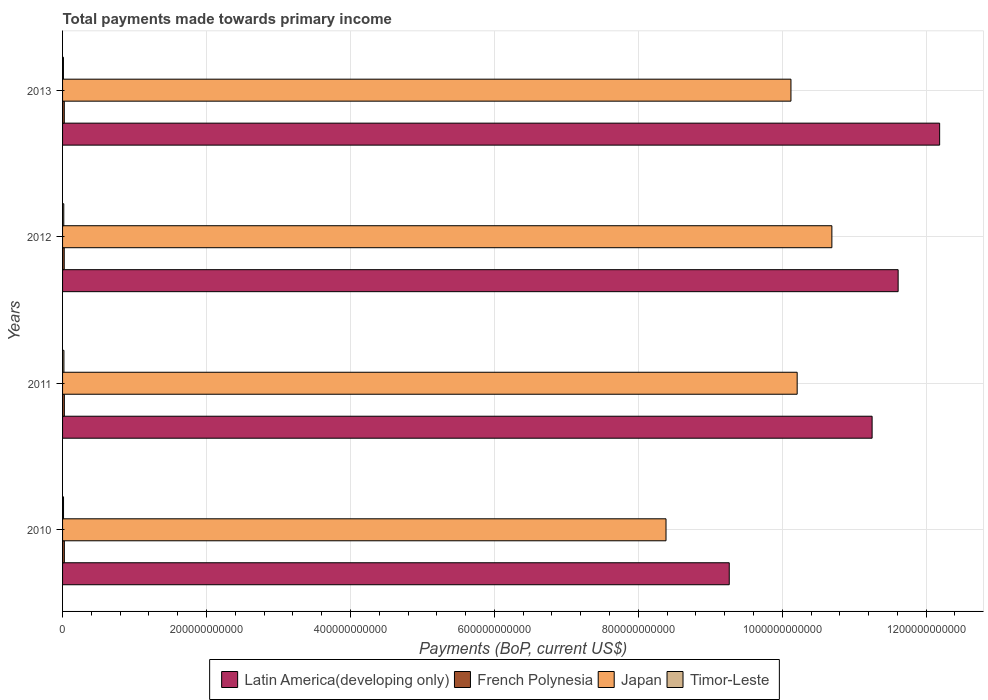How many different coloured bars are there?
Keep it short and to the point. 4. Are the number of bars per tick equal to the number of legend labels?
Provide a succinct answer. Yes. How many bars are there on the 1st tick from the top?
Your answer should be compact. 4. What is the label of the 1st group of bars from the top?
Ensure brevity in your answer.  2013. What is the total payments made towards primary income in Japan in 2010?
Offer a very short reply. 8.39e+11. Across all years, what is the maximum total payments made towards primary income in Timor-Leste?
Provide a succinct answer. 1.88e+09. Across all years, what is the minimum total payments made towards primary income in Japan?
Your response must be concise. 8.39e+11. In which year was the total payments made towards primary income in Japan minimum?
Make the answer very short. 2010. What is the total total payments made towards primary income in Timor-Leste in the graph?
Offer a very short reply. 6.13e+09. What is the difference between the total payments made towards primary income in Timor-Leste in 2011 and that in 2013?
Keep it short and to the point. 6.56e+08. What is the difference between the total payments made towards primary income in Japan in 2010 and the total payments made towards primary income in Timor-Leste in 2013?
Keep it short and to the point. 8.37e+11. What is the average total payments made towards primary income in Latin America(developing only) per year?
Your answer should be very brief. 1.11e+12. In the year 2010, what is the difference between the total payments made towards primary income in Japan and total payments made towards primary income in Latin America(developing only)?
Keep it short and to the point. -8.79e+1. In how many years, is the total payments made towards primary income in French Polynesia greater than 200000000000 US$?
Provide a succinct answer. 0. What is the ratio of the total payments made towards primary income in French Polynesia in 2010 to that in 2013?
Keep it short and to the point. 1.04. Is the difference between the total payments made towards primary income in Japan in 2010 and 2013 greater than the difference between the total payments made towards primary income in Latin America(developing only) in 2010 and 2013?
Provide a succinct answer. Yes. What is the difference between the highest and the second highest total payments made towards primary income in Latin America(developing only)?
Your answer should be very brief. 5.77e+1. What is the difference between the highest and the lowest total payments made towards primary income in Latin America(developing only)?
Your answer should be compact. 2.92e+11. Is the sum of the total payments made towards primary income in French Polynesia in 2010 and 2012 greater than the maximum total payments made towards primary income in Timor-Leste across all years?
Your response must be concise. Yes. Is it the case that in every year, the sum of the total payments made towards primary income in Timor-Leste and total payments made towards primary income in Japan is greater than the sum of total payments made towards primary income in French Polynesia and total payments made towards primary income in Latin America(developing only)?
Offer a terse response. No. What does the 1st bar from the top in 2010 represents?
Provide a short and direct response. Timor-Leste. What does the 2nd bar from the bottom in 2013 represents?
Offer a terse response. French Polynesia. Is it the case that in every year, the sum of the total payments made towards primary income in French Polynesia and total payments made towards primary income in Japan is greater than the total payments made towards primary income in Latin America(developing only)?
Ensure brevity in your answer.  No. How many bars are there?
Offer a terse response. 16. Are all the bars in the graph horizontal?
Provide a succinct answer. Yes. What is the difference between two consecutive major ticks on the X-axis?
Your response must be concise. 2.00e+11. Are the values on the major ticks of X-axis written in scientific E-notation?
Keep it short and to the point. No. Does the graph contain any zero values?
Provide a succinct answer. No. Does the graph contain grids?
Keep it short and to the point. Yes. What is the title of the graph?
Give a very brief answer. Total payments made towards primary income. What is the label or title of the X-axis?
Ensure brevity in your answer.  Payments (BoP, current US$). What is the label or title of the Y-axis?
Offer a terse response. Years. What is the Payments (BoP, current US$) in Latin America(developing only) in 2010?
Offer a terse response. 9.26e+11. What is the Payments (BoP, current US$) in French Polynesia in 2010?
Your response must be concise. 2.47e+09. What is the Payments (BoP, current US$) in Japan in 2010?
Keep it short and to the point. 8.39e+11. What is the Payments (BoP, current US$) in Timor-Leste in 2010?
Your answer should be compact. 1.35e+09. What is the Payments (BoP, current US$) of Latin America(developing only) in 2011?
Offer a terse response. 1.12e+12. What is the Payments (BoP, current US$) of French Polynesia in 2011?
Provide a short and direct response. 2.47e+09. What is the Payments (BoP, current US$) in Japan in 2011?
Provide a succinct answer. 1.02e+12. What is the Payments (BoP, current US$) of Timor-Leste in 2011?
Give a very brief answer. 1.88e+09. What is the Payments (BoP, current US$) of Latin America(developing only) in 2012?
Offer a terse response. 1.16e+12. What is the Payments (BoP, current US$) of French Polynesia in 2012?
Your response must be concise. 2.31e+09. What is the Payments (BoP, current US$) of Japan in 2012?
Offer a terse response. 1.07e+12. What is the Payments (BoP, current US$) in Timor-Leste in 2012?
Offer a very short reply. 1.68e+09. What is the Payments (BoP, current US$) of Latin America(developing only) in 2013?
Your response must be concise. 1.22e+12. What is the Payments (BoP, current US$) in French Polynesia in 2013?
Your response must be concise. 2.37e+09. What is the Payments (BoP, current US$) of Japan in 2013?
Your response must be concise. 1.01e+12. What is the Payments (BoP, current US$) in Timor-Leste in 2013?
Your answer should be compact. 1.22e+09. Across all years, what is the maximum Payments (BoP, current US$) in Latin America(developing only)?
Your response must be concise. 1.22e+12. Across all years, what is the maximum Payments (BoP, current US$) in French Polynesia?
Make the answer very short. 2.47e+09. Across all years, what is the maximum Payments (BoP, current US$) in Japan?
Give a very brief answer. 1.07e+12. Across all years, what is the maximum Payments (BoP, current US$) of Timor-Leste?
Your answer should be very brief. 1.88e+09. Across all years, what is the minimum Payments (BoP, current US$) in Latin America(developing only)?
Your response must be concise. 9.26e+11. Across all years, what is the minimum Payments (BoP, current US$) in French Polynesia?
Offer a very short reply. 2.31e+09. Across all years, what is the minimum Payments (BoP, current US$) of Japan?
Provide a short and direct response. 8.39e+11. Across all years, what is the minimum Payments (BoP, current US$) in Timor-Leste?
Keep it short and to the point. 1.22e+09. What is the total Payments (BoP, current US$) in Latin America(developing only) in the graph?
Make the answer very short. 4.43e+12. What is the total Payments (BoP, current US$) in French Polynesia in the graph?
Offer a terse response. 9.61e+09. What is the total Payments (BoP, current US$) in Japan in the graph?
Provide a succinct answer. 3.94e+12. What is the total Payments (BoP, current US$) in Timor-Leste in the graph?
Give a very brief answer. 6.13e+09. What is the difference between the Payments (BoP, current US$) in Latin America(developing only) in 2010 and that in 2011?
Ensure brevity in your answer.  -1.99e+11. What is the difference between the Payments (BoP, current US$) in French Polynesia in 2010 and that in 2011?
Your response must be concise. -4.14e+06. What is the difference between the Payments (BoP, current US$) in Japan in 2010 and that in 2011?
Ensure brevity in your answer.  -1.82e+11. What is the difference between the Payments (BoP, current US$) in Timor-Leste in 2010 and that in 2011?
Provide a succinct answer. -5.24e+08. What is the difference between the Payments (BoP, current US$) in Latin America(developing only) in 2010 and that in 2012?
Keep it short and to the point. -2.35e+11. What is the difference between the Payments (BoP, current US$) of French Polynesia in 2010 and that in 2012?
Provide a short and direct response. 1.59e+08. What is the difference between the Payments (BoP, current US$) in Japan in 2010 and that in 2012?
Your response must be concise. -2.30e+11. What is the difference between the Payments (BoP, current US$) in Timor-Leste in 2010 and that in 2012?
Your response must be concise. -3.30e+08. What is the difference between the Payments (BoP, current US$) in Latin America(developing only) in 2010 and that in 2013?
Keep it short and to the point. -2.92e+11. What is the difference between the Payments (BoP, current US$) in French Polynesia in 2010 and that in 2013?
Make the answer very short. 9.14e+07. What is the difference between the Payments (BoP, current US$) of Japan in 2010 and that in 2013?
Your answer should be compact. -1.74e+11. What is the difference between the Payments (BoP, current US$) of Timor-Leste in 2010 and that in 2013?
Keep it short and to the point. 1.32e+08. What is the difference between the Payments (BoP, current US$) in Latin America(developing only) in 2011 and that in 2012?
Ensure brevity in your answer.  -3.62e+1. What is the difference between the Payments (BoP, current US$) of French Polynesia in 2011 and that in 2012?
Your response must be concise. 1.63e+08. What is the difference between the Payments (BoP, current US$) of Japan in 2011 and that in 2012?
Your response must be concise. -4.82e+1. What is the difference between the Payments (BoP, current US$) in Timor-Leste in 2011 and that in 2012?
Your response must be concise. 1.94e+08. What is the difference between the Payments (BoP, current US$) of Latin America(developing only) in 2011 and that in 2013?
Provide a short and direct response. -9.38e+1. What is the difference between the Payments (BoP, current US$) in French Polynesia in 2011 and that in 2013?
Keep it short and to the point. 9.56e+07. What is the difference between the Payments (BoP, current US$) of Japan in 2011 and that in 2013?
Provide a short and direct response. 8.64e+09. What is the difference between the Payments (BoP, current US$) of Timor-Leste in 2011 and that in 2013?
Your answer should be very brief. 6.56e+08. What is the difference between the Payments (BoP, current US$) in Latin America(developing only) in 2012 and that in 2013?
Your answer should be very brief. -5.77e+1. What is the difference between the Payments (BoP, current US$) in French Polynesia in 2012 and that in 2013?
Your response must be concise. -6.77e+07. What is the difference between the Payments (BoP, current US$) of Japan in 2012 and that in 2013?
Offer a terse response. 5.69e+1. What is the difference between the Payments (BoP, current US$) in Timor-Leste in 2012 and that in 2013?
Offer a terse response. 4.62e+08. What is the difference between the Payments (BoP, current US$) of Latin America(developing only) in 2010 and the Payments (BoP, current US$) of French Polynesia in 2011?
Your answer should be very brief. 9.24e+11. What is the difference between the Payments (BoP, current US$) of Latin America(developing only) in 2010 and the Payments (BoP, current US$) of Japan in 2011?
Provide a succinct answer. -9.44e+1. What is the difference between the Payments (BoP, current US$) of Latin America(developing only) in 2010 and the Payments (BoP, current US$) of Timor-Leste in 2011?
Your response must be concise. 9.25e+11. What is the difference between the Payments (BoP, current US$) in French Polynesia in 2010 and the Payments (BoP, current US$) in Japan in 2011?
Offer a terse response. -1.02e+12. What is the difference between the Payments (BoP, current US$) of French Polynesia in 2010 and the Payments (BoP, current US$) of Timor-Leste in 2011?
Offer a terse response. 5.90e+08. What is the difference between the Payments (BoP, current US$) of Japan in 2010 and the Payments (BoP, current US$) of Timor-Leste in 2011?
Offer a very short reply. 8.37e+11. What is the difference between the Payments (BoP, current US$) in Latin America(developing only) in 2010 and the Payments (BoP, current US$) in French Polynesia in 2012?
Your answer should be compact. 9.24e+11. What is the difference between the Payments (BoP, current US$) of Latin America(developing only) in 2010 and the Payments (BoP, current US$) of Japan in 2012?
Your response must be concise. -1.43e+11. What is the difference between the Payments (BoP, current US$) of Latin America(developing only) in 2010 and the Payments (BoP, current US$) of Timor-Leste in 2012?
Your response must be concise. 9.25e+11. What is the difference between the Payments (BoP, current US$) in French Polynesia in 2010 and the Payments (BoP, current US$) in Japan in 2012?
Make the answer very short. -1.07e+12. What is the difference between the Payments (BoP, current US$) in French Polynesia in 2010 and the Payments (BoP, current US$) in Timor-Leste in 2012?
Make the answer very short. 7.84e+08. What is the difference between the Payments (BoP, current US$) in Japan in 2010 and the Payments (BoP, current US$) in Timor-Leste in 2012?
Ensure brevity in your answer.  8.37e+11. What is the difference between the Payments (BoP, current US$) in Latin America(developing only) in 2010 and the Payments (BoP, current US$) in French Polynesia in 2013?
Your answer should be compact. 9.24e+11. What is the difference between the Payments (BoP, current US$) of Latin America(developing only) in 2010 and the Payments (BoP, current US$) of Japan in 2013?
Provide a succinct answer. -8.57e+1. What is the difference between the Payments (BoP, current US$) in Latin America(developing only) in 2010 and the Payments (BoP, current US$) in Timor-Leste in 2013?
Give a very brief answer. 9.25e+11. What is the difference between the Payments (BoP, current US$) in French Polynesia in 2010 and the Payments (BoP, current US$) in Japan in 2013?
Provide a succinct answer. -1.01e+12. What is the difference between the Payments (BoP, current US$) of French Polynesia in 2010 and the Payments (BoP, current US$) of Timor-Leste in 2013?
Your answer should be compact. 1.25e+09. What is the difference between the Payments (BoP, current US$) of Japan in 2010 and the Payments (BoP, current US$) of Timor-Leste in 2013?
Make the answer very short. 8.37e+11. What is the difference between the Payments (BoP, current US$) in Latin America(developing only) in 2011 and the Payments (BoP, current US$) in French Polynesia in 2012?
Make the answer very short. 1.12e+12. What is the difference between the Payments (BoP, current US$) of Latin America(developing only) in 2011 and the Payments (BoP, current US$) of Japan in 2012?
Keep it short and to the point. 5.59e+1. What is the difference between the Payments (BoP, current US$) in Latin America(developing only) in 2011 and the Payments (BoP, current US$) in Timor-Leste in 2012?
Provide a succinct answer. 1.12e+12. What is the difference between the Payments (BoP, current US$) in French Polynesia in 2011 and the Payments (BoP, current US$) in Japan in 2012?
Ensure brevity in your answer.  -1.07e+12. What is the difference between the Payments (BoP, current US$) of French Polynesia in 2011 and the Payments (BoP, current US$) of Timor-Leste in 2012?
Give a very brief answer. 7.88e+08. What is the difference between the Payments (BoP, current US$) of Japan in 2011 and the Payments (BoP, current US$) of Timor-Leste in 2012?
Ensure brevity in your answer.  1.02e+12. What is the difference between the Payments (BoP, current US$) in Latin America(developing only) in 2011 and the Payments (BoP, current US$) in French Polynesia in 2013?
Provide a succinct answer. 1.12e+12. What is the difference between the Payments (BoP, current US$) of Latin America(developing only) in 2011 and the Payments (BoP, current US$) of Japan in 2013?
Give a very brief answer. 1.13e+11. What is the difference between the Payments (BoP, current US$) in Latin America(developing only) in 2011 and the Payments (BoP, current US$) in Timor-Leste in 2013?
Give a very brief answer. 1.12e+12. What is the difference between the Payments (BoP, current US$) in French Polynesia in 2011 and the Payments (BoP, current US$) in Japan in 2013?
Make the answer very short. -1.01e+12. What is the difference between the Payments (BoP, current US$) in French Polynesia in 2011 and the Payments (BoP, current US$) in Timor-Leste in 2013?
Ensure brevity in your answer.  1.25e+09. What is the difference between the Payments (BoP, current US$) of Japan in 2011 and the Payments (BoP, current US$) of Timor-Leste in 2013?
Make the answer very short. 1.02e+12. What is the difference between the Payments (BoP, current US$) in Latin America(developing only) in 2012 and the Payments (BoP, current US$) in French Polynesia in 2013?
Your answer should be very brief. 1.16e+12. What is the difference between the Payments (BoP, current US$) in Latin America(developing only) in 2012 and the Payments (BoP, current US$) in Japan in 2013?
Make the answer very short. 1.49e+11. What is the difference between the Payments (BoP, current US$) in Latin America(developing only) in 2012 and the Payments (BoP, current US$) in Timor-Leste in 2013?
Your answer should be compact. 1.16e+12. What is the difference between the Payments (BoP, current US$) of French Polynesia in 2012 and the Payments (BoP, current US$) of Japan in 2013?
Provide a short and direct response. -1.01e+12. What is the difference between the Payments (BoP, current US$) in French Polynesia in 2012 and the Payments (BoP, current US$) in Timor-Leste in 2013?
Your answer should be compact. 1.09e+09. What is the difference between the Payments (BoP, current US$) of Japan in 2012 and the Payments (BoP, current US$) of Timor-Leste in 2013?
Your answer should be compact. 1.07e+12. What is the average Payments (BoP, current US$) in Latin America(developing only) per year?
Provide a short and direct response. 1.11e+12. What is the average Payments (BoP, current US$) of French Polynesia per year?
Your response must be concise. 2.40e+09. What is the average Payments (BoP, current US$) in Japan per year?
Give a very brief answer. 9.85e+11. What is the average Payments (BoP, current US$) of Timor-Leste per year?
Make the answer very short. 1.53e+09. In the year 2010, what is the difference between the Payments (BoP, current US$) in Latin America(developing only) and Payments (BoP, current US$) in French Polynesia?
Your response must be concise. 9.24e+11. In the year 2010, what is the difference between the Payments (BoP, current US$) in Latin America(developing only) and Payments (BoP, current US$) in Japan?
Ensure brevity in your answer.  8.79e+1. In the year 2010, what is the difference between the Payments (BoP, current US$) in Latin America(developing only) and Payments (BoP, current US$) in Timor-Leste?
Your answer should be very brief. 9.25e+11. In the year 2010, what is the difference between the Payments (BoP, current US$) of French Polynesia and Payments (BoP, current US$) of Japan?
Ensure brevity in your answer.  -8.36e+11. In the year 2010, what is the difference between the Payments (BoP, current US$) in French Polynesia and Payments (BoP, current US$) in Timor-Leste?
Your answer should be very brief. 1.11e+09. In the year 2010, what is the difference between the Payments (BoP, current US$) in Japan and Payments (BoP, current US$) in Timor-Leste?
Give a very brief answer. 8.37e+11. In the year 2011, what is the difference between the Payments (BoP, current US$) of Latin America(developing only) and Payments (BoP, current US$) of French Polynesia?
Give a very brief answer. 1.12e+12. In the year 2011, what is the difference between the Payments (BoP, current US$) of Latin America(developing only) and Payments (BoP, current US$) of Japan?
Provide a succinct answer. 1.04e+11. In the year 2011, what is the difference between the Payments (BoP, current US$) in Latin America(developing only) and Payments (BoP, current US$) in Timor-Leste?
Provide a short and direct response. 1.12e+12. In the year 2011, what is the difference between the Payments (BoP, current US$) of French Polynesia and Payments (BoP, current US$) of Japan?
Make the answer very short. -1.02e+12. In the year 2011, what is the difference between the Payments (BoP, current US$) in French Polynesia and Payments (BoP, current US$) in Timor-Leste?
Give a very brief answer. 5.94e+08. In the year 2011, what is the difference between the Payments (BoP, current US$) in Japan and Payments (BoP, current US$) in Timor-Leste?
Give a very brief answer. 1.02e+12. In the year 2012, what is the difference between the Payments (BoP, current US$) of Latin America(developing only) and Payments (BoP, current US$) of French Polynesia?
Give a very brief answer. 1.16e+12. In the year 2012, what is the difference between the Payments (BoP, current US$) in Latin America(developing only) and Payments (BoP, current US$) in Japan?
Make the answer very short. 9.21e+1. In the year 2012, what is the difference between the Payments (BoP, current US$) of Latin America(developing only) and Payments (BoP, current US$) of Timor-Leste?
Offer a very short reply. 1.16e+12. In the year 2012, what is the difference between the Payments (BoP, current US$) in French Polynesia and Payments (BoP, current US$) in Japan?
Provide a succinct answer. -1.07e+12. In the year 2012, what is the difference between the Payments (BoP, current US$) in French Polynesia and Payments (BoP, current US$) in Timor-Leste?
Offer a terse response. 6.25e+08. In the year 2012, what is the difference between the Payments (BoP, current US$) of Japan and Payments (BoP, current US$) of Timor-Leste?
Offer a terse response. 1.07e+12. In the year 2013, what is the difference between the Payments (BoP, current US$) of Latin America(developing only) and Payments (BoP, current US$) of French Polynesia?
Make the answer very short. 1.22e+12. In the year 2013, what is the difference between the Payments (BoP, current US$) in Latin America(developing only) and Payments (BoP, current US$) in Japan?
Keep it short and to the point. 2.07e+11. In the year 2013, what is the difference between the Payments (BoP, current US$) in Latin America(developing only) and Payments (BoP, current US$) in Timor-Leste?
Provide a succinct answer. 1.22e+12. In the year 2013, what is the difference between the Payments (BoP, current US$) of French Polynesia and Payments (BoP, current US$) of Japan?
Provide a succinct answer. -1.01e+12. In the year 2013, what is the difference between the Payments (BoP, current US$) of French Polynesia and Payments (BoP, current US$) of Timor-Leste?
Provide a succinct answer. 1.15e+09. In the year 2013, what is the difference between the Payments (BoP, current US$) in Japan and Payments (BoP, current US$) in Timor-Leste?
Provide a short and direct response. 1.01e+12. What is the ratio of the Payments (BoP, current US$) in Latin America(developing only) in 2010 to that in 2011?
Make the answer very short. 0.82. What is the ratio of the Payments (BoP, current US$) of Japan in 2010 to that in 2011?
Offer a very short reply. 0.82. What is the ratio of the Payments (BoP, current US$) in Timor-Leste in 2010 to that in 2011?
Make the answer very short. 0.72. What is the ratio of the Payments (BoP, current US$) of Latin America(developing only) in 2010 to that in 2012?
Your answer should be compact. 0.8. What is the ratio of the Payments (BoP, current US$) of French Polynesia in 2010 to that in 2012?
Provide a short and direct response. 1.07. What is the ratio of the Payments (BoP, current US$) in Japan in 2010 to that in 2012?
Offer a very short reply. 0.78. What is the ratio of the Payments (BoP, current US$) of Timor-Leste in 2010 to that in 2012?
Your response must be concise. 0.8. What is the ratio of the Payments (BoP, current US$) of Latin America(developing only) in 2010 to that in 2013?
Provide a succinct answer. 0.76. What is the ratio of the Payments (BoP, current US$) of Japan in 2010 to that in 2013?
Provide a short and direct response. 0.83. What is the ratio of the Payments (BoP, current US$) of Timor-Leste in 2010 to that in 2013?
Make the answer very short. 1.11. What is the ratio of the Payments (BoP, current US$) of Latin America(developing only) in 2011 to that in 2012?
Provide a short and direct response. 0.97. What is the ratio of the Payments (BoP, current US$) in French Polynesia in 2011 to that in 2012?
Your answer should be compact. 1.07. What is the ratio of the Payments (BoP, current US$) of Japan in 2011 to that in 2012?
Your response must be concise. 0.95. What is the ratio of the Payments (BoP, current US$) in Timor-Leste in 2011 to that in 2012?
Offer a very short reply. 1.12. What is the ratio of the Payments (BoP, current US$) in Latin America(developing only) in 2011 to that in 2013?
Provide a succinct answer. 0.92. What is the ratio of the Payments (BoP, current US$) in French Polynesia in 2011 to that in 2013?
Ensure brevity in your answer.  1.04. What is the ratio of the Payments (BoP, current US$) of Japan in 2011 to that in 2013?
Give a very brief answer. 1.01. What is the ratio of the Payments (BoP, current US$) of Timor-Leste in 2011 to that in 2013?
Give a very brief answer. 1.54. What is the ratio of the Payments (BoP, current US$) in Latin America(developing only) in 2012 to that in 2013?
Your answer should be compact. 0.95. What is the ratio of the Payments (BoP, current US$) in French Polynesia in 2012 to that in 2013?
Your answer should be very brief. 0.97. What is the ratio of the Payments (BoP, current US$) of Japan in 2012 to that in 2013?
Your answer should be very brief. 1.06. What is the ratio of the Payments (BoP, current US$) of Timor-Leste in 2012 to that in 2013?
Your answer should be very brief. 1.38. What is the difference between the highest and the second highest Payments (BoP, current US$) in Latin America(developing only)?
Provide a short and direct response. 5.77e+1. What is the difference between the highest and the second highest Payments (BoP, current US$) of French Polynesia?
Ensure brevity in your answer.  4.14e+06. What is the difference between the highest and the second highest Payments (BoP, current US$) of Japan?
Provide a succinct answer. 4.82e+1. What is the difference between the highest and the second highest Payments (BoP, current US$) in Timor-Leste?
Your answer should be compact. 1.94e+08. What is the difference between the highest and the lowest Payments (BoP, current US$) of Latin America(developing only)?
Your answer should be very brief. 2.92e+11. What is the difference between the highest and the lowest Payments (BoP, current US$) in French Polynesia?
Make the answer very short. 1.63e+08. What is the difference between the highest and the lowest Payments (BoP, current US$) of Japan?
Give a very brief answer. 2.30e+11. What is the difference between the highest and the lowest Payments (BoP, current US$) of Timor-Leste?
Offer a very short reply. 6.56e+08. 